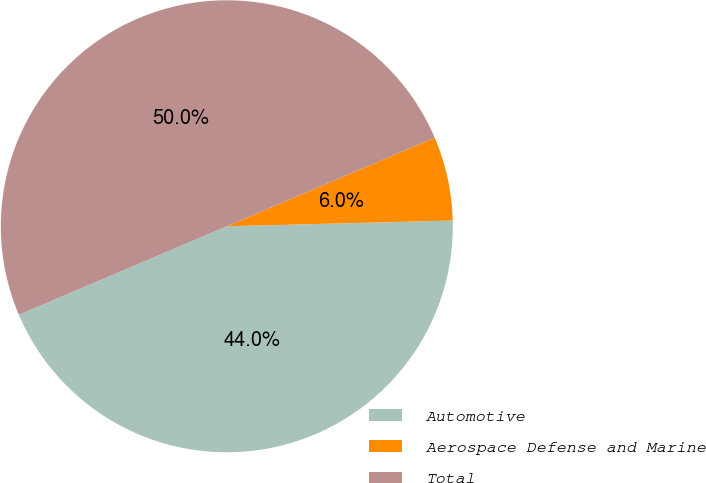Convert chart. <chart><loc_0><loc_0><loc_500><loc_500><pie_chart><fcel>Automotive<fcel>Aerospace Defense and Marine<fcel>Total<nl><fcel>44.0%<fcel>6.0%<fcel>50.0%<nl></chart> 